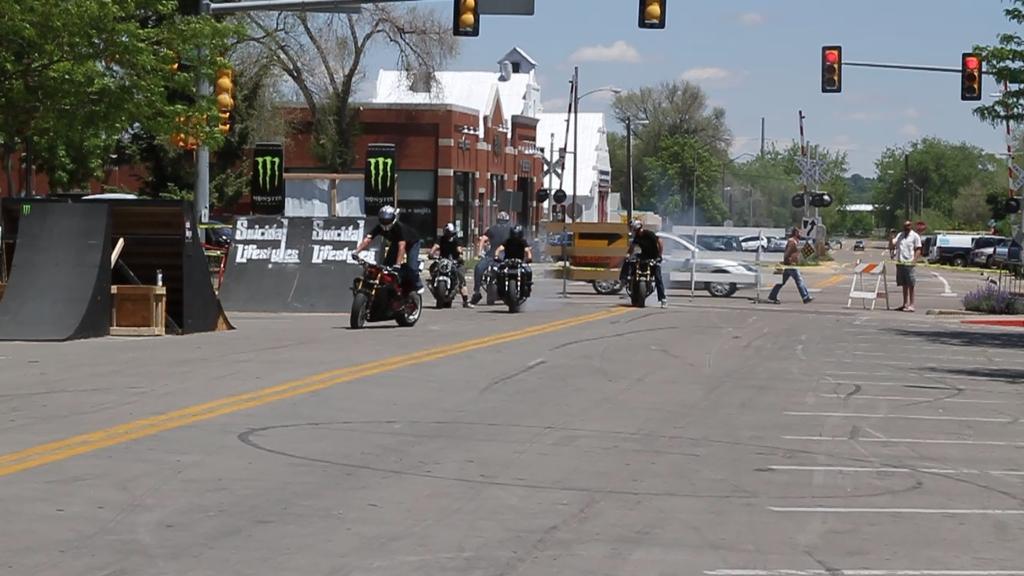Please provide a concise description of this image. In this picture I can see in the middle few people are riding the vehicles, on the left side there are trees and buildings. At the top there are traffic signals and there is the sky, on the right side there is a man standing on the road. 